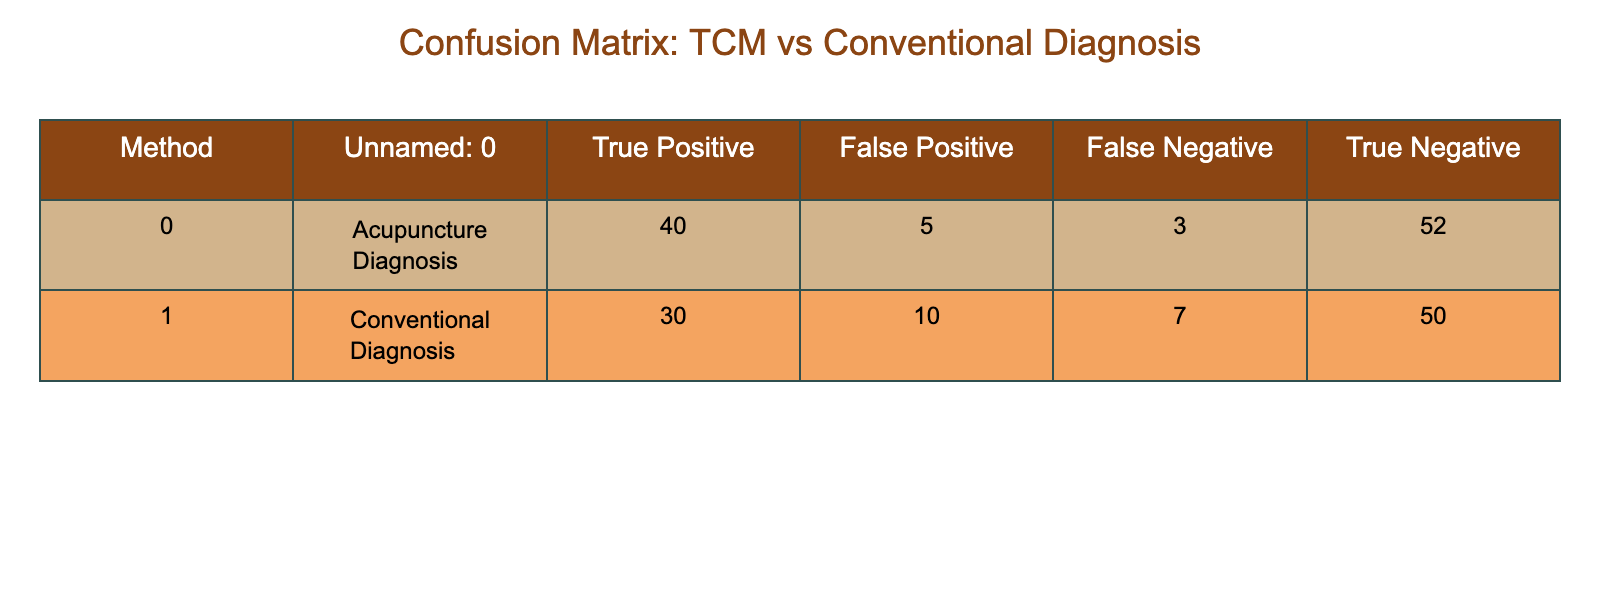What is the number of True Positives in Acupuncture Diagnosis? The table shows that the True Positive value for Acupuncture Diagnosis is 40.
Answer: 40 What is the number of False Negatives in Conventional Diagnosis? The table indicates that the False Negative value for Conventional Diagnosis is 7.
Answer: 7 Which diagnosis method has a higher False Positive rate? To find the False Positive rate, we look at the values: Acupuncture has 5 while Conventional has 10. Since 10 > 5, Conventional Diagnosis has a higher False Positive rate.
Answer: Conventional Diagnosis What is the total number of diagnoses made by Acupuncture? To find the total for Acupuncture, add True Positives, False Positives, False Negatives, and True Negatives: 40 + 5 + 3 + 52 = 100.
Answer: 100 What is the accuracy of Acupuncture Diagnosis? Accuracy is calculated as (True Positives + True Negatives) / Total Diagnoses. For Acupuncture: (40 + 52) / 100 = 0.92 or 92%.
Answer: 92% Is the True Negative count for Conventional Diagnosis equal to the True Positive count for Acupuncture Diagnosis? The True Negative count for Conventional Diagnosis is 50, while the True Positive count for Acupuncture Diagnosis is 40. Since 50 ≠ 40, they are not equal.
Answer: No How many total incorrect diagnoses are made by Acupuncture? The total incorrect diagnoses (False Positives + False Negatives) for Acupuncture are 5 + 3 = 8.
Answer: 8 Comparing both methods, which has the overall better diagnostic performance? To assess overall performance, consider the combinations of True Positives and True Negatives. For Acupuncture, they total to 92, and for Conventional, they total to 80 (30 + 50). Since 92 > 80, Acupuncture shows better performance.
Answer: Acupuncture Diagnosis 